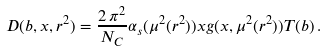Convert formula to latex. <formula><loc_0><loc_0><loc_500><loc_500>D ( b , x , r ^ { 2 } ) = \frac { 2 \, \pi ^ { 2 } } { N _ { C } } \alpha _ { s } ( \mu ^ { 2 } ( r ^ { 2 } ) ) x g ( x , \mu ^ { 2 } ( r ^ { 2 } ) ) T ( b ) \, .</formula> 